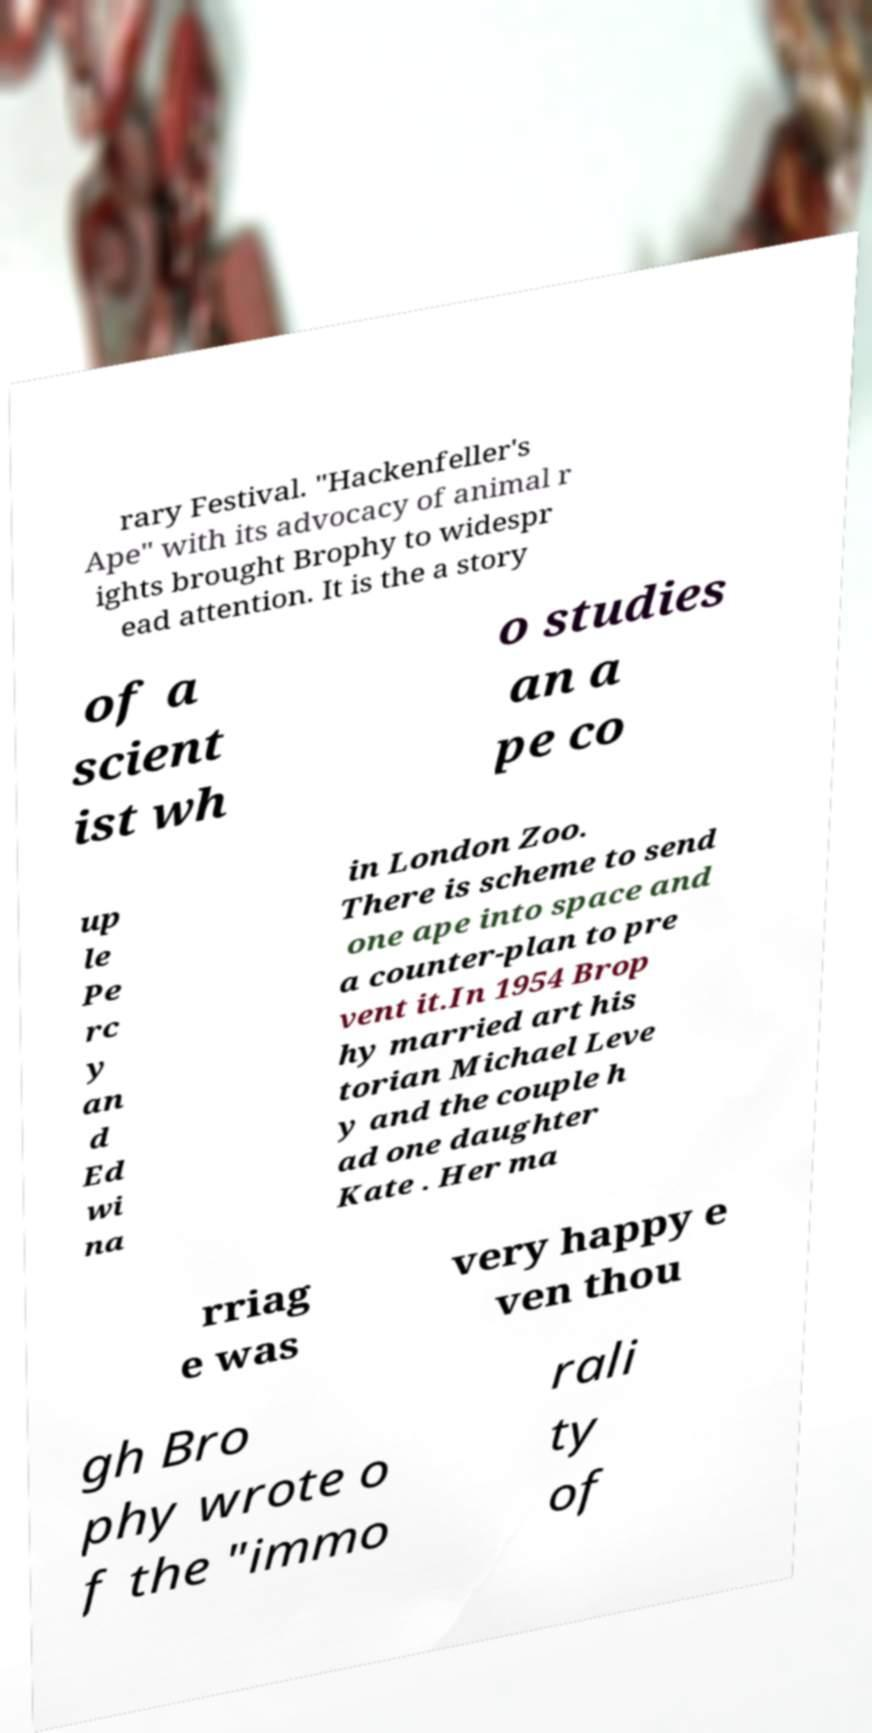I need the written content from this picture converted into text. Can you do that? rary Festival. "Hackenfeller's Ape" with its advocacy of animal r ights brought Brophy to widespr ead attention. It is the a story of a scient ist wh o studies an a pe co up le Pe rc y an d Ed wi na in London Zoo. There is scheme to send one ape into space and a counter-plan to pre vent it.In 1954 Brop hy married art his torian Michael Leve y and the couple h ad one daughter Kate . Her ma rriag e was very happy e ven thou gh Bro phy wrote o f the "immo rali ty of 